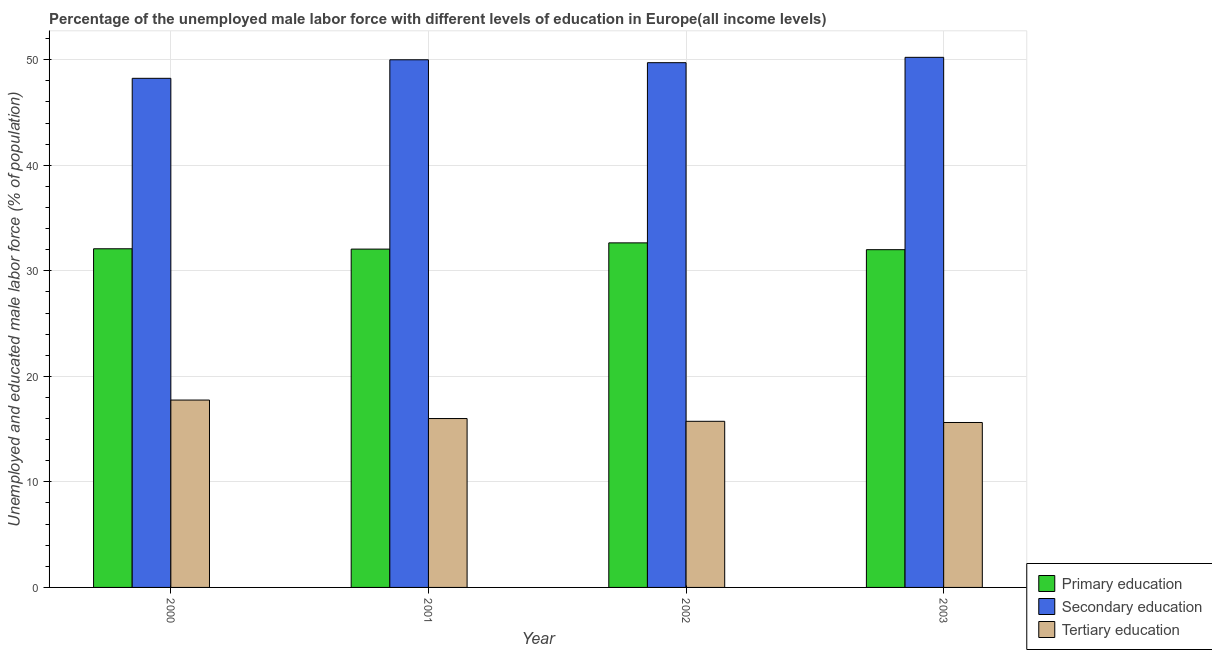Are the number of bars per tick equal to the number of legend labels?
Give a very brief answer. Yes. How many bars are there on the 3rd tick from the left?
Keep it short and to the point. 3. In how many cases, is the number of bars for a given year not equal to the number of legend labels?
Offer a terse response. 0. What is the percentage of male labor force who received primary education in 2000?
Provide a succinct answer. 32.09. Across all years, what is the maximum percentage of male labor force who received secondary education?
Make the answer very short. 50.23. Across all years, what is the minimum percentage of male labor force who received tertiary education?
Offer a very short reply. 15.63. What is the total percentage of male labor force who received tertiary education in the graph?
Offer a terse response. 65.13. What is the difference between the percentage of male labor force who received primary education in 2000 and that in 2003?
Your answer should be very brief. 0.09. What is the difference between the percentage of male labor force who received secondary education in 2000 and the percentage of male labor force who received tertiary education in 2003?
Offer a terse response. -1.99. What is the average percentage of male labor force who received secondary education per year?
Offer a very short reply. 49.55. In how many years, is the percentage of male labor force who received primary education greater than 2 %?
Keep it short and to the point. 4. What is the ratio of the percentage of male labor force who received tertiary education in 2001 to that in 2003?
Give a very brief answer. 1.02. Is the percentage of male labor force who received tertiary education in 2001 less than that in 2003?
Offer a very short reply. No. Is the difference between the percentage of male labor force who received primary education in 2001 and 2002 greater than the difference between the percentage of male labor force who received tertiary education in 2001 and 2002?
Keep it short and to the point. No. What is the difference between the highest and the second highest percentage of male labor force who received primary education?
Your response must be concise. 0.56. What is the difference between the highest and the lowest percentage of male labor force who received primary education?
Give a very brief answer. 0.65. What does the 2nd bar from the left in 2000 represents?
Your answer should be compact. Secondary education. What does the 3rd bar from the right in 2000 represents?
Your answer should be very brief. Primary education. Is it the case that in every year, the sum of the percentage of male labor force who received primary education and percentage of male labor force who received secondary education is greater than the percentage of male labor force who received tertiary education?
Your response must be concise. Yes. How many bars are there?
Keep it short and to the point. 12. Are all the bars in the graph horizontal?
Provide a succinct answer. No. What is the difference between two consecutive major ticks on the Y-axis?
Your answer should be compact. 10. Are the values on the major ticks of Y-axis written in scientific E-notation?
Your answer should be compact. No. Does the graph contain grids?
Offer a terse response. Yes. Where does the legend appear in the graph?
Offer a terse response. Bottom right. How many legend labels are there?
Keep it short and to the point. 3. What is the title of the graph?
Your answer should be very brief. Percentage of the unemployed male labor force with different levels of education in Europe(all income levels). What is the label or title of the Y-axis?
Your answer should be compact. Unemployed and educated male labor force (% of population). What is the Unemployed and educated male labor force (% of population) of Primary education in 2000?
Give a very brief answer. 32.09. What is the Unemployed and educated male labor force (% of population) in Secondary education in 2000?
Ensure brevity in your answer.  48.24. What is the Unemployed and educated male labor force (% of population) in Tertiary education in 2000?
Give a very brief answer. 17.75. What is the Unemployed and educated male labor force (% of population) in Primary education in 2001?
Your answer should be very brief. 32.06. What is the Unemployed and educated male labor force (% of population) in Secondary education in 2001?
Provide a succinct answer. 50. What is the Unemployed and educated male labor force (% of population) in Tertiary education in 2001?
Ensure brevity in your answer.  16. What is the Unemployed and educated male labor force (% of population) in Primary education in 2002?
Give a very brief answer. 32.65. What is the Unemployed and educated male labor force (% of population) in Secondary education in 2002?
Offer a very short reply. 49.72. What is the Unemployed and educated male labor force (% of population) in Tertiary education in 2002?
Keep it short and to the point. 15.74. What is the Unemployed and educated male labor force (% of population) of Primary education in 2003?
Your answer should be very brief. 32. What is the Unemployed and educated male labor force (% of population) of Secondary education in 2003?
Offer a very short reply. 50.23. What is the Unemployed and educated male labor force (% of population) of Tertiary education in 2003?
Make the answer very short. 15.63. Across all years, what is the maximum Unemployed and educated male labor force (% of population) of Primary education?
Provide a succinct answer. 32.65. Across all years, what is the maximum Unemployed and educated male labor force (% of population) of Secondary education?
Offer a very short reply. 50.23. Across all years, what is the maximum Unemployed and educated male labor force (% of population) in Tertiary education?
Give a very brief answer. 17.75. Across all years, what is the minimum Unemployed and educated male labor force (% of population) of Primary education?
Provide a short and direct response. 32. Across all years, what is the minimum Unemployed and educated male labor force (% of population) in Secondary education?
Your response must be concise. 48.24. Across all years, what is the minimum Unemployed and educated male labor force (% of population) of Tertiary education?
Your answer should be compact. 15.63. What is the total Unemployed and educated male labor force (% of population) in Primary education in the graph?
Your answer should be very brief. 128.8. What is the total Unemployed and educated male labor force (% of population) of Secondary education in the graph?
Provide a short and direct response. 198.19. What is the total Unemployed and educated male labor force (% of population) of Tertiary education in the graph?
Provide a short and direct response. 65.13. What is the difference between the Unemployed and educated male labor force (% of population) in Primary education in 2000 and that in 2001?
Ensure brevity in your answer.  0.03. What is the difference between the Unemployed and educated male labor force (% of population) of Secondary education in 2000 and that in 2001?
Provide a short and direct response. -1.76. What is the difference between the Unemployed and educated male labor force (% of population) in Tertiary education in 2000 and that in 2001?
Make the answer very short. 1.75. What is the difference between the Unemployed and educated male labor force (% of population) of Primary education in 2000 and that in 2002?
Give a very brief answer. -0.56. What is the difference between the Unemployed and educated male labor force (% of population) in Secondary education in 2000 and that in 2002?
Keep it short and to the point. -1.48. What is the difference between the Unemployed and educated male labor force (% of population) in Tertiary education in 2000 and that in 2002?
Keep it short and to the point. 2.01. What is the difference between the Unemployed and educated male labor force (% of population) of Primary education in 2000 and that in 2003?
Ensure brevity in your answer.  0.09. What is the difference between the Unemployed and educated male labor force (% of population) of Secondary education in 2000 and that in 2003?
Offer a very short reply. -1.99. What is the difference between the Unemployed and educated male labor force (% of population) of Tertiary education in 2000 and that in 2003?
Keep it short and to the point. 2.13. What is the difference between the Unemployed and educated male labor force (% of population) of Primary education in 2001 and that in 2002?
Provide a succinct answer. -0.59. What is the difference between the Unemployed and educated male labor force (% of population) of Secondary education in 2001 and that in 2002?
Make the answer very short. 0.28. What is the difference between the Unemployed and educated male labor force (% of population) in Tertiary education in 2001 and that in 2002?
Offer a terse response. 0.26. What is the difference between the Unemployed and educated male labor force (% of population) in Primary education in 2001 and that in 2003?
Provide a succinct answer. 0.06. What is the difference between the Unemployed and educated male labor force (% of population) in Secondary education in 2001 and that in 2003?
Give a very brief answer. -0.23. What is the difference between the Unemployed and educated male labor force (% of population) of Tertiary education in 2001 and that in 2003?
Your answer should be compact. 0.37. What is the difference between the Unemployed and educated male labor force (% of population) of Primary education in 2002 and that in 2003?
Provide a succinct answer. 0.65. What is the difference between the Unemployed and educated male labor force (% of population) in Secondary education in 2002 and that in 2003?
Offer a very short reply. -0.51. What is the difference between the Unemployed and educated male labor force (% of population) in Tertiary education in 2002 and that in 2003?
Ensure brevity in your answer.  0.11. What is the difference between the Unemployed and educated male labor force (% of population) in Primary education in 2000 and the Unemployed and educated male labor force (% of population) in Secondary education in 2001?
Your answer should be very brief. -17.91. What is the difference between the Unemployed and educated male labor force (% of population) of Primary education in 2000 and the Unemployed and educated male labor force (% of population) of Tertiary education in 2001?
Provide a succinct answer. 16.09. What is the difference between the Unemployed and educated male labor force (% of population) in Secondary education in 2000 and the Unemployed and educated male labor force (% of population) in Tertiary education in 2001?
Give a very brief answer. 32.24. What is the difference between the Unemployed and educated male labor force (% of population) of Primary education in 2000 and the Unemployed and educated male labor force (% of population) of Secondary education in 2002?
Offer a very short reply. -17.63. What is the difference between the Unemployed and educated male labor force (% of population) in Primary education in 2000 and the Unemployed and educated male labor force (% of population) in Tertiary education in 2002?
Give a very brief answer. 16.35. What is the difference between the Unemployed and educated male labor force (% of population) of Secondary education in 2000 and the Unemployed and educated male labor force (% of population) of Tertiary education in 2002?
Provide a short and direct response. 32.5. What is the difference between the Unemployed and educated male labor force (% of population) in Primary education in 2000 and the Unemployed and educated male labor force (% of population) in Secondary education in 2003?
Your answer should be very brief. -18.14. What is the difference between the Unemployed and educated male labor force (% of population) of Primary education in 2000 and the Unemployed and educated male labor force (% of population) of Tertiary education in 2003?
Offer a very short reply. 16.46. What is the difference between the Unemployed and educated male labor force (% of population) of Secondary education in 2000 and the Unemployed and educated male labor force (% of population) of Tertiary education in 2003?
Your answer should be very brief. 32.61. What is the difference between the Unemployed and educated male labor force (% of population) of Primary education in 2001 and the Unemployed and educated male labor force (% of population) of Secondary education in 2002?
Keep it short and to the point. -17.66. What is the difference between the Unemployed and educated male labor force (% of population) in Primary education in 2001 and the Unemployed and educated male labor force (% of population) in Tertiary education in 2002?
Provide a short and direct response. 16.32. What is the difference between the Unemployed and educated male labor force (% of population) of Secondary education in 2001 and the Unemployed and educated male labor force (% of population) of Tertiary education in 2002?
Your response must be concise. 34.26. What is the difference between the Unemployed and educated male labor force (% of population) in Primary education in 2001 and the Unemployed and educated male labor force (% of population) in Secondary education in 2003?
Your answer should be very brief. -18.17. What is the difference between the Unemployed and educated male labor force (% of population) of Primary education in 2001 and the Unemployed and educated male labor force (% of population) of Tertiary education in 2003?
Offer a terse response. 16.43. What is the difference between the Unemployed and educated male labor force (% of population) of Secondary education in 2001 and the Unemployed and educated male labor force (% of population) of Tertiary education in 2003?
Offer a very short reply. 34.37. What is the difference between the Unemployed and educated male labor force (% of population) of Primary education in 2002 and the Unemployed and educated male labor force (% of population) of Secondary education in 2003?
Offer a terse response. -17.58. What is the difference between the Unemployed and educated male labor force (% of population) in Primary education in 2002 and the Unemployed and educated male labor force (% of population) in Tertiary education in 2003?
Your answer should be compact. 17.02. What is the difference between the Unemployed and educated male labor force (% of population) in Secondary education in 2002 and the Unemployed and educated male labor force (% of population) in Tertiary education in 2003?
Make the answer very short. 34.09. What is the average Unemployed and educated male labor force (% of population) of Primary education per year?
Your answer should be very brief. 32.2. What is the average Unemployed and educated male labor force (% of population) in Secondary education per year?
Offer a very short reply. 49.55. What is the average Unemployed and educated male labor force (% of population) of Tertiary education per year?
Your answer should be compact. 16.28. In the year 2000, what is the difference between the Unemployed and educated male labor force (% of population) of Primary education and Unemployed and educated male labor force (% of population) of Secondary education?
Offer a very short reply. -16.15. In the year 2000, what is the difference between the Unemployed and educated male labor force (% of population) of Primary education and Unemployed and educated male labor force (% of population) of Tertiary education?
Provide a short and direct response. 14.33. In the year 2000, what is the difference between the Unemployed and educated male labor force (% of population) in Secondary education and Unemployed and educated male labor force (% of population) in Tertiary education?
Your answer should be compact. 30.49. In the year 2001, what is the difference between the Unemployed and educated male labor force (% of population) in Primary education and Unemployed and educated male labor force (% of population) in Secondary education?
Ensure brevity in your answer.  -17.94. In the year 2001, what is the difference between the Unemployed and educated male labor force (% of population) of Primary education and Unemployed and educated male labor force (% of population) of Tertiary education?
Your answer should be compact. 16.06. In the year 2001, what is the difference between the Unemployed and educated male labor force (% of population) of Secondary education and Unemployed and educated male labor force (% of population) of Tertiary education?
Keep it short and to the point. 33.99. In the year 2002, what is the difference between the Unemployed and educated male labor force (% of population) in Primary education and Unemployed and educated male labor force (% of population) in Secondary education?
Make the answer very short. -17.07. In the year 2002, what is the difference between the Unemployed and educated male labor force (% of population) of Primary education and Unemployed and educated male labor force (% of population) of Tertiary education?
Keep it short and to the point. 16.91. In the year 2002, what is the difference between the Unemployed and educated male labor force (% of population) of Secondary education and Unemployed and educated male labor force (% of population) of Tertiary education?
Offer a very short reply. 33.98. In the year 2003, what is the difference between the Unemployed and educated male labor force (% of population) of Primary education and Unemployed and educated male labor force (% of population) of Secondary education?
Your answer should be compact. -18.23. In the year 2003, what is the difference between the Unemployed and educated male labor force (% of population) of Primary education and Unemployed and educated male labor force (% of population) of Tertiary education?
Offer a very short reply. 16.37. In the year 2003, what is the difference between the Unemployed and educated male labor force (% of population) in Secondary education and Unemployed and educated male labor force (% of population) in Tertiary education?
Give a very brief answer. 34.6. What is the ratio of the Unemployed and educated male labor force (% of population) in Secondary education in 2000 to that in 2001?
Your answer should be very brief. 0.96. What is the ratio of the Unemployed and educated male labor force (% of population) in Tertiary education in 2000 to that in 2001?
Keep it short and to the point. 1.11. What is the ratio of the Unemployed and educated male labor force (% of population) in Primary education in 2000 to that in 2002?
Make the answer very short. 0.98. What is the ratio of the Unemployed and educated male labor force (% of population) of Secondary education in 2000 to that in 2002?
Your answer should be very brief. 0.97. What is the ratio of the Unemployed and educated male labor force (% of population) in Tertiary education in 2000 to that in 2002?
Provide a succinct answer. 1.13. What is the ratio of the Unemployed and educated male labor force (% of population) in Primary education in 2000 to that in 2003?
Your answer should be very brief. 1. What is the ratio of the Unemployed and educated male labor force (% of population) in Secondary education in 2000 to that in 2003?
Offer a terse response. 0.96. What is the ratio of the Unemployed and educated male labor force (% of population) of Tertiary education in 2000 to that in 2003?
Ensure brevity in your answer.  1.14. What is the ratio of the Unemployed and educated male labor force (% of population) in Primary education in 2001 to that in 2002?
Keep it short and to the point. 0.98. What is the ratio of the Unemployed and educated male labor force (% of population) of Secondary education in 2001 to that in 2002?
Your answer should be very brief. 1.01. What is the ratio of the Unemployed and educated male labor force (% of population) in Tertiary education in 2001 to that in 2002?
Ensure brevity in your answer.  1.02. What is the ratio of the Unemployed and educated male labor force (% of population) of Primary education in 2001 to that in 2003?
Make the answer very short. 1. What is the ratio of the Unemployed and educated male labor force (% of population) in Tertiary education in 2001 to that in 2003?
Make the answer very short. 1.02. What is the ratio of the Unemployed and educated male labor force (% of population) of Primary education in 2002 to that in 2003?
Your response must be concise. 1.02. What is the ratio of the Unemployed and educated male labor force (% of population) of Secondary education in 2002 to that in 2003?
Offer a very short reply. 0.99. What is the difference between the highest and the second highest Unemployed and educated male labor force (% of population) in Primary education?
Offer a terse response. 0.56. What is the difference between the highest and the second highest Unemployed and educated male labor force (% of population) in Secondary education?
Provide a succinct answer. 0.23. What is the difference between the highest and the second highest Unemployed and educated male labor force (% of population) in Tertiary education?
Make the answer very short. 1.75. What is the difference between the highest and the lowest Unemployed and educated male labor force (% of population) in Primary education?
Provide a short and direct response. 0.65. What is the difference between the highest and the lowest Unemployed and educated male labor force (% of population) of Secondary education?
Your response must be concise. 1.99. What is the difference between the highest and the lowest Unemployed and educated male labor force (% of population) in Tertiary education?
Make the answer very short. 2.13. 